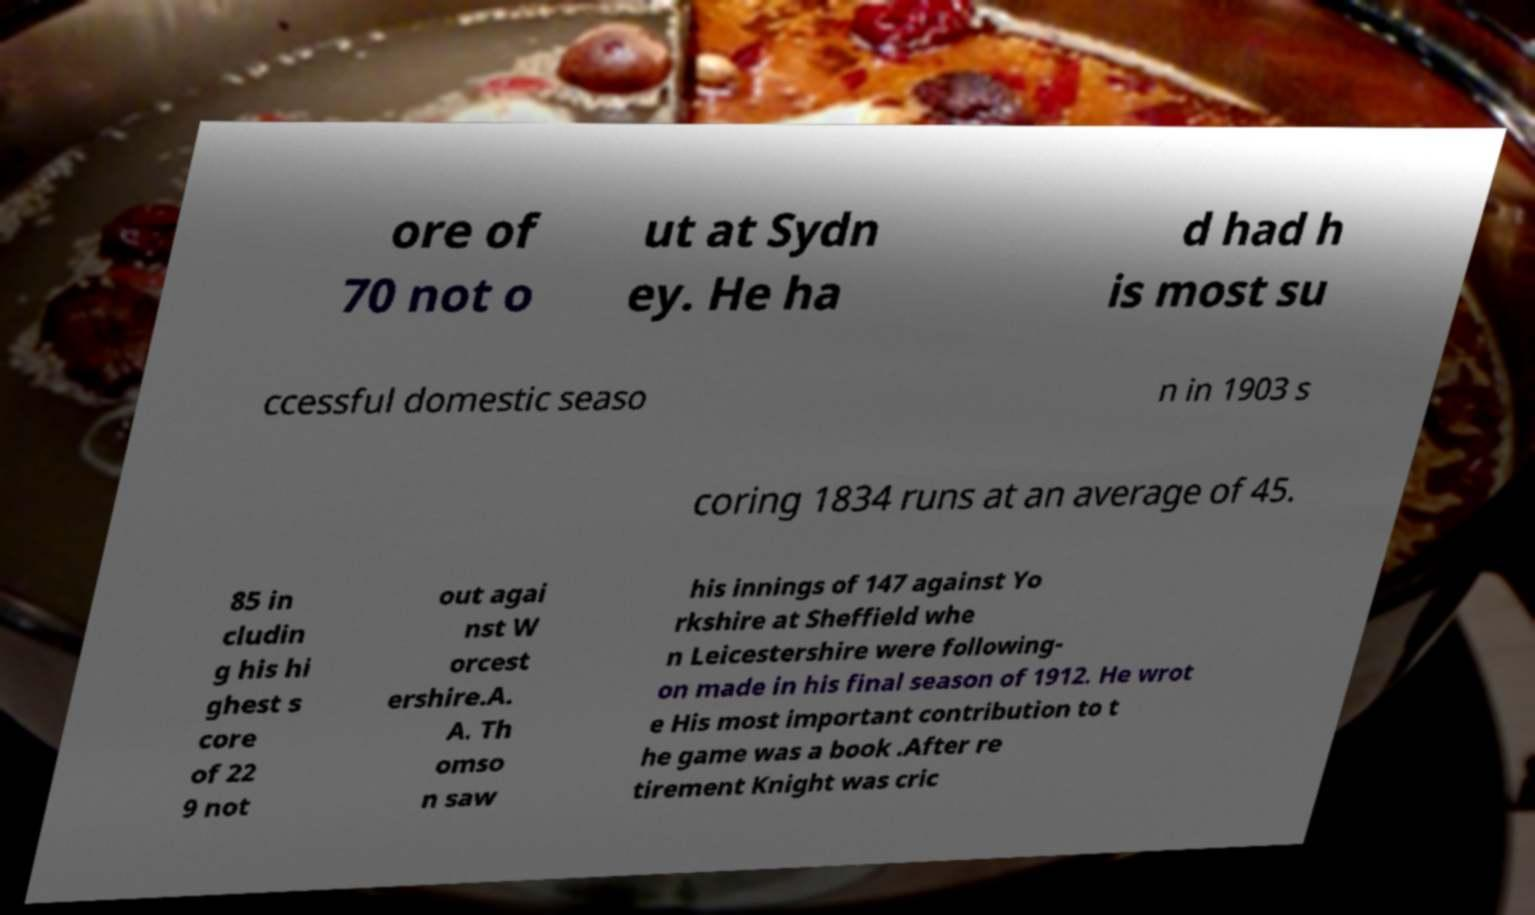Can you read and provide the text displayed in the image?This photo seems to have some interesting text. Can you extract and type it out for me? ore of 70 not o ut at Sydn ey. He ha d had h is most su ccessful domestic seaso n in 1903 s coring 1834 runs at an average of 45. 85 in cludin g his hi ghest s core of 22 9 not out agai nst W orcest ershire.A. A. Th omso n saw his innings of 147 against Yo rkshire at Sheffield whe n Leicestershire were following- on made in his final season of 1912. He wrot e His most important contribution to t he game was a book .After re tirement Knight was cric 